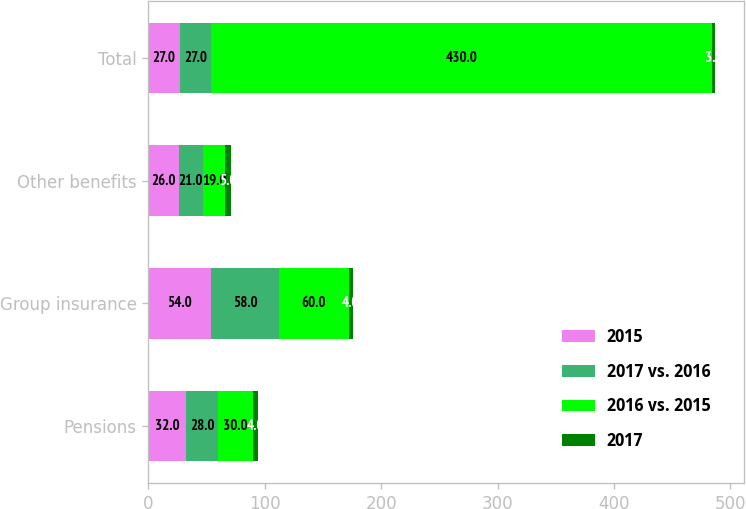<chart> <loc_0><loc_0><loc_500><loc_500><stacked_bar_chart><ecel><fcel>Pensions<fcel>Group insurance<fcel>Other benefits<fcel>Total<nl><fcel>2015<fcel>32<fcel>54<fcel>26<fcel>27<nl><fcel>2017 vs. 2016<fcel>28<fcel>58<fcel>21<fcel>27<nl><fcel>2016 vs. 2015<fcel>30<fcel>60<fcel>19<fcel>430<nl><fcel>2017<fcel>4<fcel>4<fcel>5<fcel>3<nl></chart> 